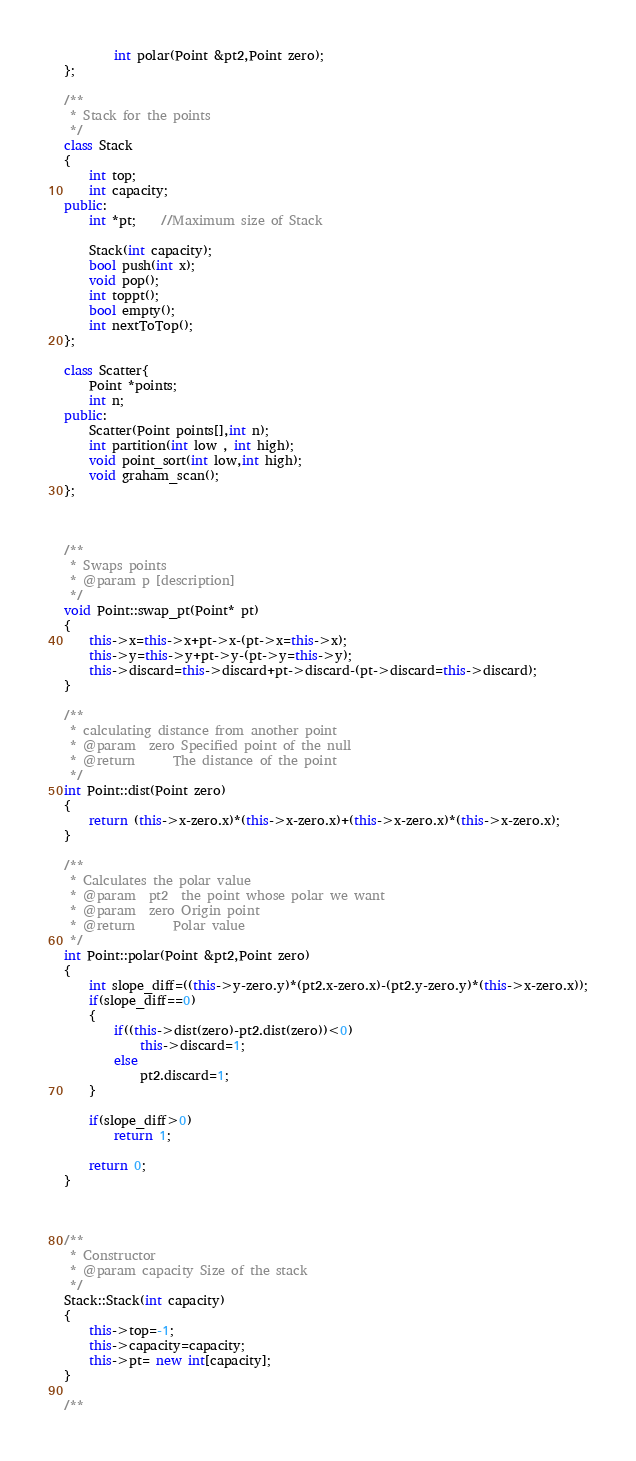Convert code to text. <code><loc_0><loc_0><loc_500><loc_500><_C++_>		int polar(Point &pt2,Point zero);
};

/**
 * Stack for the points
 */
class Stack
{
    int top;
    int capacity;
public:
    int *pt;    //Maximum size of Stack

  	Stack(int capacity);
    bool push(int x);
    void pop();
    int toppt();
    bool empty();
    int nextToTop();
};

class Scatter{
	Point *points;
	int n;
public:
	Scatter(Point points[],int n);
	int partition(int low , int high);
	void point_sort(int low,int high);
	void graham_scan();
};



/**
 * Swaps points
 * @param p [description]
 */
void Point::swap_pt(Point* pt)
{
	this->x=this->x+pt->x-(pt->x=this->x);
	this->y=this->y+pt->y-(pt->y=this->y);
	this->discard=this->discard+pt->discard-(pt->discard=this->discard);
}

/**
 * calculating distance from another point
 * @param  zero Specified point of the null
 * @return     	The distance of the point
 */
int Point::dist(Point zero)
{
	return (this->x-zero.x)*(this->x-zero.x)+(this->x-zero.x)*(this->x-zero.x);
}

/**
 * Calculates the polar value
 * @param  pt2  the point whose polar we want
 * @param  zero Origin point
 * @return      Polar value
 */
int Point::polar(Point &pt2,Point zero)
{
	int slope_diff=((this->y-zero.y)*(pt2.x-zero.x)-(pt2.y-zero.y)*(this->x-zero.x));
	if(slope_diff==0)
	{
		if((this->dist(zero)-pt2.dist(zero))<0)
			this->discard=1;
		else
			pt2.discard=1;
	}

	if(slope_diff>0)
		return 1;

	return 0;
}



/**
 * Constructor
 * @param capacity Size of the stack
 */
Stack::Stack(int capacity)
{
	this->top=-1;
	this->capacity=capacity;
	this->pt= new int[capacity];
}

/**</code> 